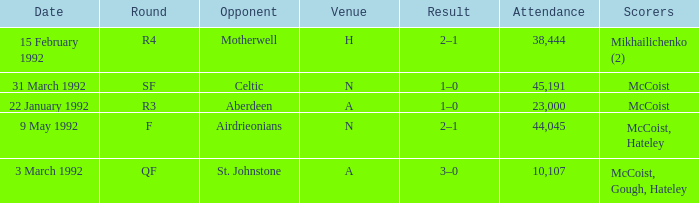What is the result with an attendance larger than 10,107 and Celtic as the opponent? 1–0. 